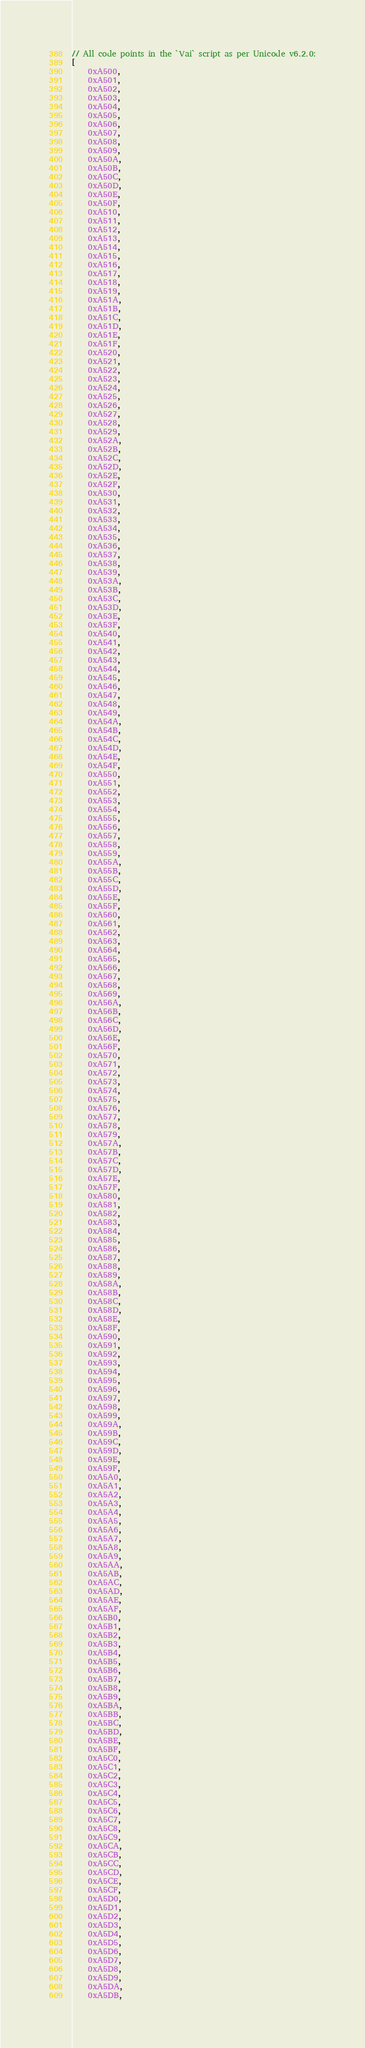<code> <loc_0><loc_0><loc_500><loc_500><_JavaScript_>// All code points in the `Vai` script as per Unicode v6.2.0:
[
	0xA500,
	0xA501,
	0xA502,
	0xA503,
	0xA504,
	0xA505,
	0xA506,
	0xA507,
	0xA508,
	0xA509,
	0xA50A,
	0xA50B,
	0xA50C,
	0xA50D,
	0xA50E,
	0xA50F,
	0xA510,
	0xA511,
	0xA512,
	0xA513,
	0xA514,
	0xA515,
	0xA516,
	0xA517,
	0xA518,
	0xA519,
	0xA51A,
	0xA51B,
	0xA51C,
	0xA51D,
	0xA51E,
	0xA51F,
	0xA520,
	0xA521,
	0xA522,
	0xA523,
	0xA524,
	0xA525,
	0xA526,
	0xA527,
	0xA528,
	0xA529,
	0xA52A,
	0xA52B,
	0xA52C,
	0xA52D,
	0xA52E,
	0xA52F,
	0xA530,
	0xA531,
	0xA532,
	0xA533,
	0xA534,
	0xA535,
	0xA536,
	0xA537,
	0xA538,
	0xA539,
	0xA53A,
	0xA53B,
	0xA53C,
	0xA53D,
	0xA53E,
	0xA53F,
	0xA540,
	0xA541,
	0xA542,
	0xA543,
	0xA544,
	0xA545,
	0xA546,
	0xA547,
	0xA548,
	0xA549,
	0xA54A,
	0xA54B,
	0xA54C,
	0xA54D,
	0xA54E,
	0xA54F,
	0xA550,
	0xA551,
	0xA552,
	0xA553,
	0xA554,
	0xA555,
	0xA556,
	0xA557,
	0xA558,
	0xA559,
	0xA55A,
	0xA55B,
	0xA55C,
	0xA55D,
	0xA55E,
	0xA55F,
	0xA560,
	0xA561,
	0xA562,
	0xA563,
	0xA564,
	0xA565,
	0xA566,
	0xA567,
	0xA568,
	0xA569,
	0xA56A,
	0xA56B,
	0xA56C,
	0xA56D,
	0xA56E,
	0xA56F,
	0xA570,
	0xA571,
	0xA572,
	0xA573,
	0xA574,
	0xA575,
	0xA576,
	0xA577,
	0xA578,
	0xA579,
	0xA57A,
	0xA57B,
	0xA57C,
	0xA57D,
	0xA57E,
	0xA57F,
	0xA580,
	0xA581,
	0xA582,
	0xA583,
	0xA584,
	0xA585,
	0xA586,
	0xA587,
	0xA588,
	0xA589,
	0xA58A,
	0xA58B,
	0xA58C,
	0xA58D,
	0xA58E,
	0xA58F,
	0xA590,
	0xA591,
	0xA592,
	0xA593,
	0xA594,
	0xA595,
	0xA596,
	0xA597,
	0xA598,
	0xA599,
	0xA59A,
	0xA59B,
	0xA59C,
	0xA59D,
	0xA59E,
	0xA59F,
	0xA5A0,
	0xA5A1,
	0xA5A2,
	0xA5A3,
	0xA5A4,
	0xA5A5,
	0xA5A6,
	0xA5A7,
	0xA5A8,
	0xA5A9,
	0xA5AA,
	0xA5AB,
	0xA5AC,
	0xA5AD,
	0xA5AE,
	0xA5AF,
	0xA5B0,
	0xA5B1,
	0xA5B2,
	0xA5B3,
	0xA5B4,
	0xA5B5,
	0xA5B6,
	0xA5B7,
	0xA5B8,
	0xA5B9,
	0xA5BA,
	0xA5BB,
	0xA5BC,
	0xA5BD,
	0xA5BE,
	0xA5BF,
	0xA5C0,
	0xA5C1,
	0xA5C2,
	0xA5C3,
	0xA5C4,
	0xA5C5,
	0xA5C6,
	0xA5C7,
	0xA5C8,
	0xA5C9,
	0xA5CA,
	0xA5CB,
	0xA5CC,
	0xA5CD,
	0xA5CE,
	0xA5CF,
	0xA5D0,
	0xA5D1,
	0xA5D2,
	0xA5D3,
	0xA5D4,
	0xA5D5,
	0xA5D6,
	0xA5D7,
	0xA5D8,
	0xA5D9,
	0xA5DA,
	0xA5DB,</code> 